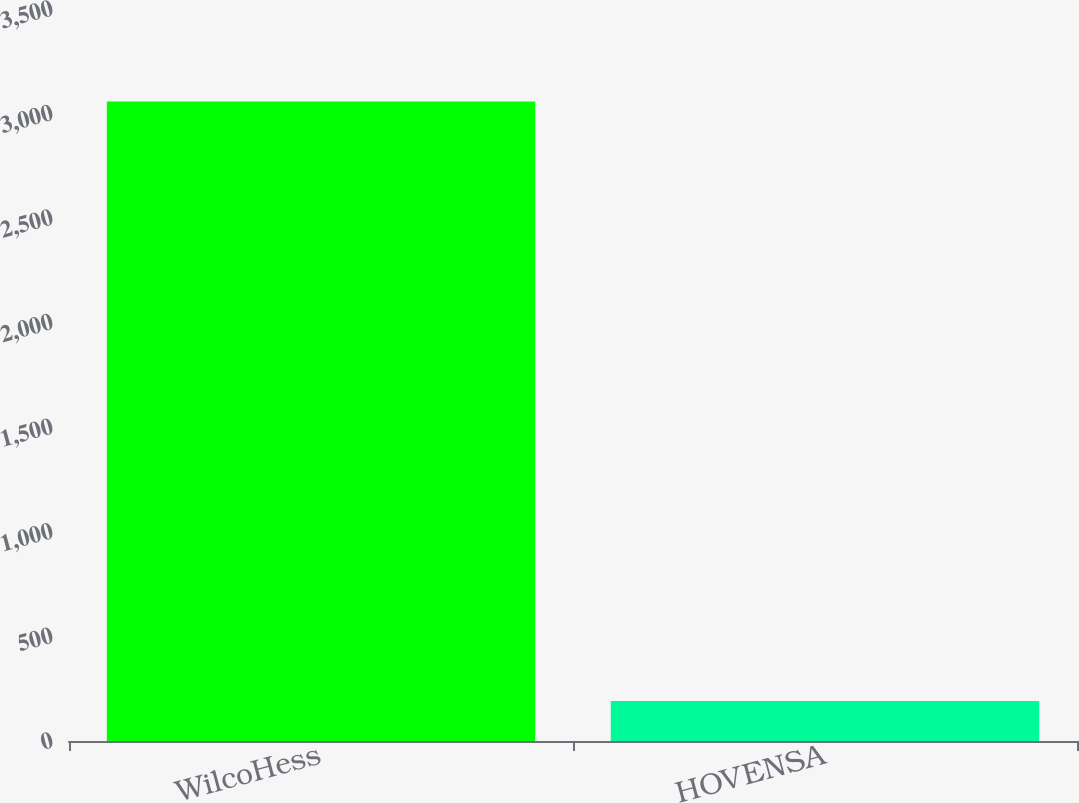Convert chart to OTSL. <chart><loc_0><loc_0><loc_500><loc_500><bar_chart><fcel>WilcoHess<fcel>HOVENSA<nl><fcel>3058<fcel>191<nl></chart> 